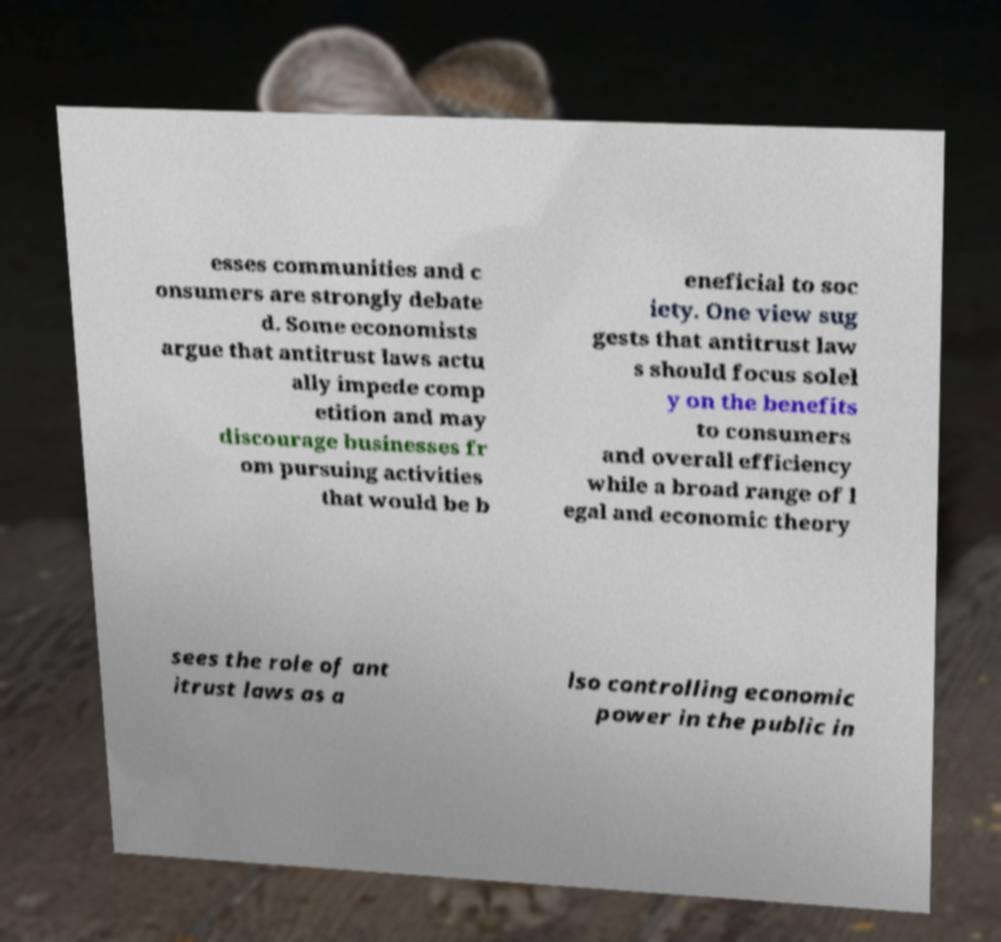Please identify and transcribe the text found in this image. esses communities and c onsumers are strongly debate d. Some economists argue that antitrust laws actu ally impede comp etition and may discourage businesses fr om pursuing activities that would be b eneficial to soc iety. One view sug gests that antitrust law s should focus solel y on the benefits to consumers and overall efficiency while a broad range of l egal and economic theory sees the role of ant itrust laws as a lso controlling economic power in the public in 